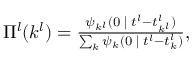Convert formula to latex. <formula><loc_0><loc_0><loc_500><loc_500>\begin{array} { r } { \Pi ^ { l } ( k ^ { l } ) = \frac { \psi _ { k ^ { l } } ( 0 { \, | \, } t ^ { l } - t _ { k ^ { l } } ^ { l } ) } { \sum _ { k } \psi _ { k } ( 0 { \, | \, } t ^ { l } - t _ { k } ^ { l } ) } , } \end{array}</formula> 